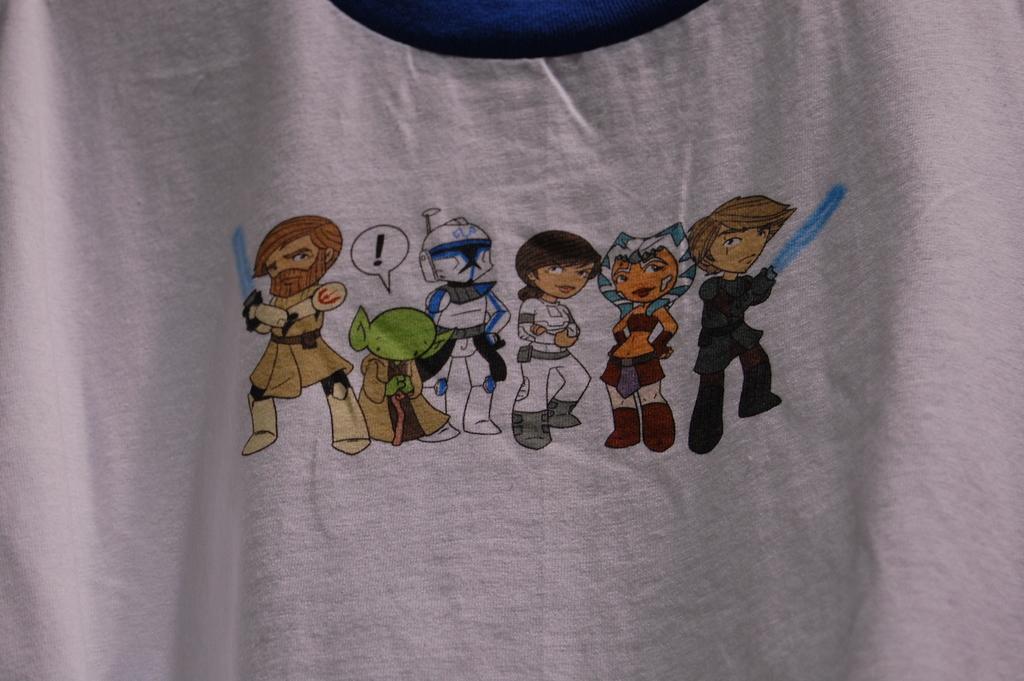Could you give a brief overview of what you see in this image? The picture consists of a white color cloth. In the center of a picture we can see the images of cartoons on the white color cloth. 